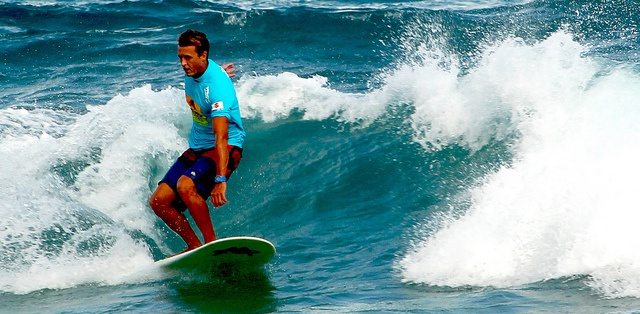Describe the objects in this image and their specific colors. I can see people in teal, black, maroon, and cyan tones and surfboard in teal, darkgreen, and ivory tones in this image. 